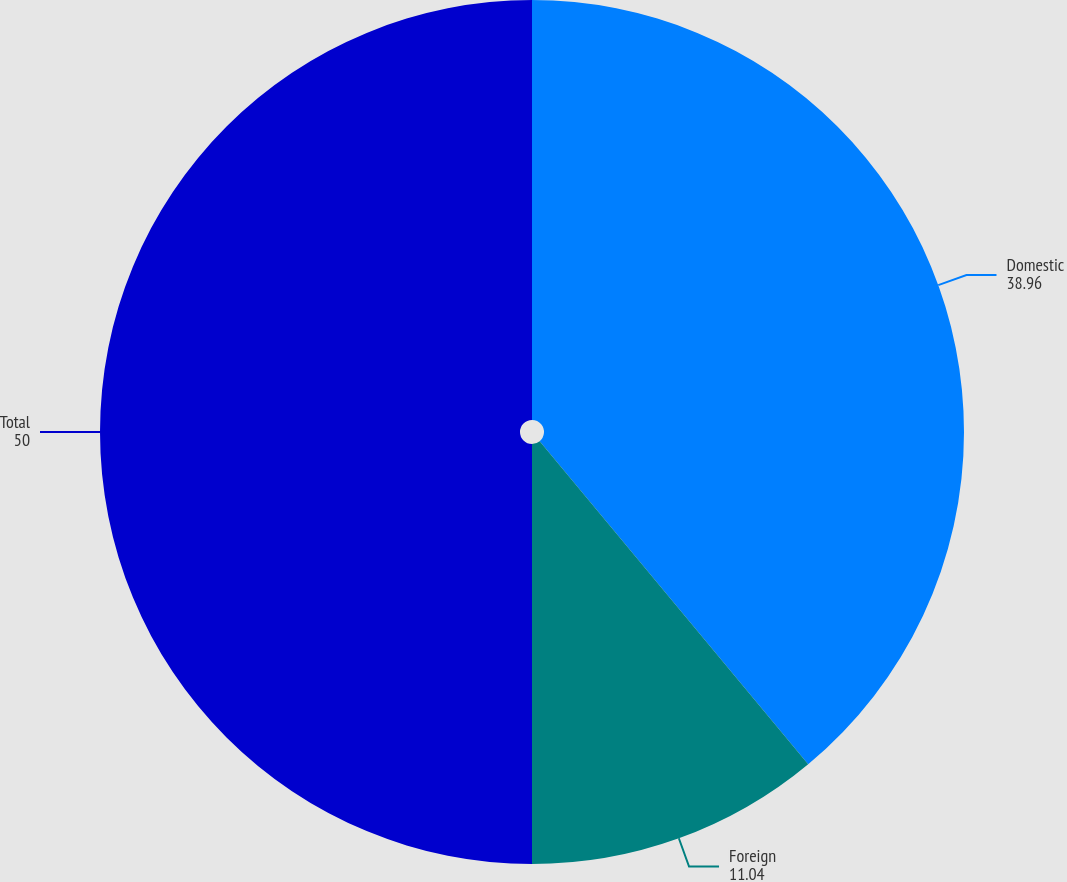Convert chart to OTSL. <chart><loc_0><loc_0><loc_500><loc_500><pie_chart><fcel>Domestic<fcel>Foreign<fcel>Total<nl><fcel>38.96%<fcel>11.04%<fcel>50.0%<nl></chart> 